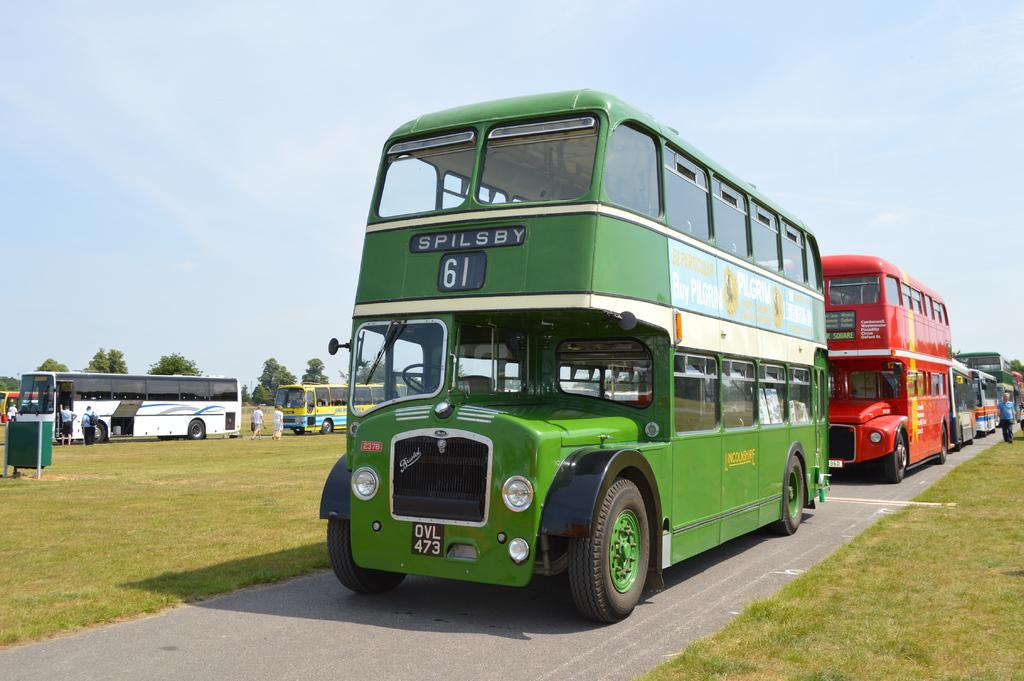<image>
Share a concise interpretation of the image provided. A green bus with number 61 is going to Spilsby. 